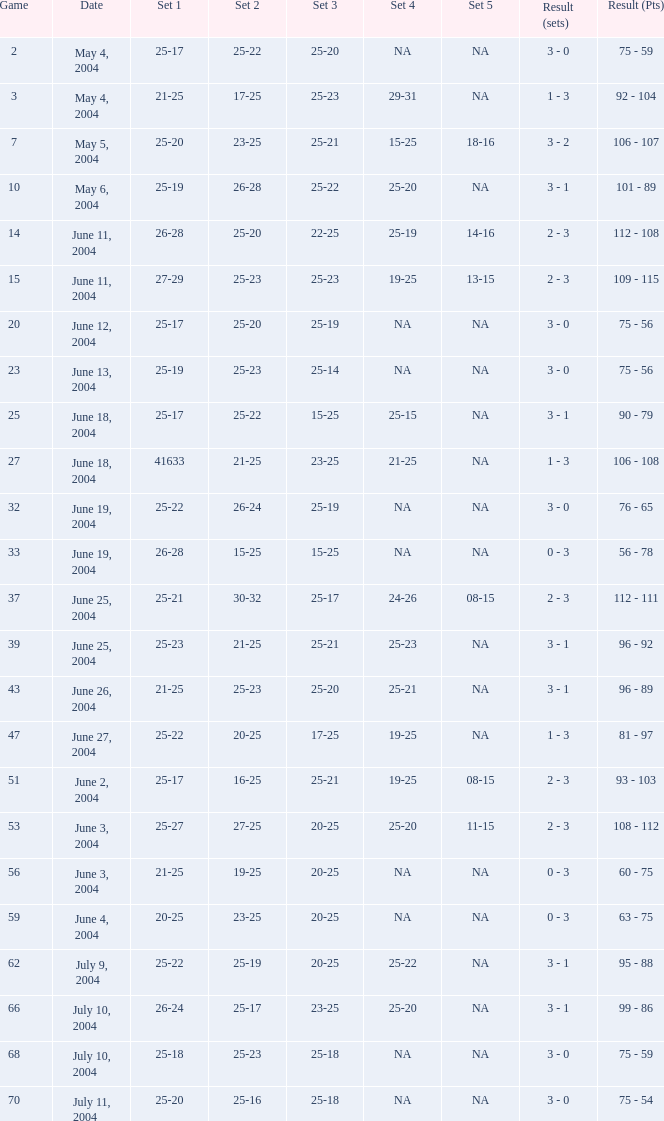What is the outcome of the game that has a set 1 score of 26-24? 99 - 86. 